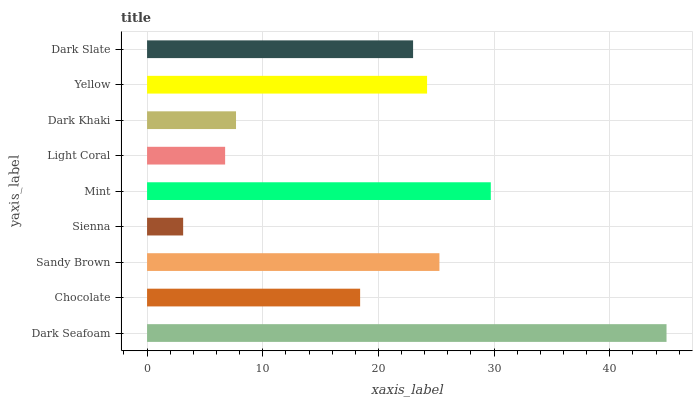Is Sienna the minimum?
Answer yes or no. Yes. Is Dark Seafoam the maximum?
Answer yes or no. Yes. Is Chocolate the minimum?
Answer yes or no. No. Is Chocolate the maximum?
Answer yes or no. No. Is Dark Seafoam greater than Chocolate?
Answer yes or no. Yes. Is Chocolate less than Dark Seafoam?
Answer yes or no. Yes. Is Chocolate greater than Dark Seafoam?
Answer yes or no. No. Is Dark Seafoam less than Chocolate?
Answer yes or no. No. Is Dark Slate the high median?
Answer yes or no. Yes. Is Dark Slate the low median?
Answer yes or no. Yes. Is Dark Seafoam the high median?
Answer yes or no. No. Is Yellow the low median?
Answer yes or no. No. 